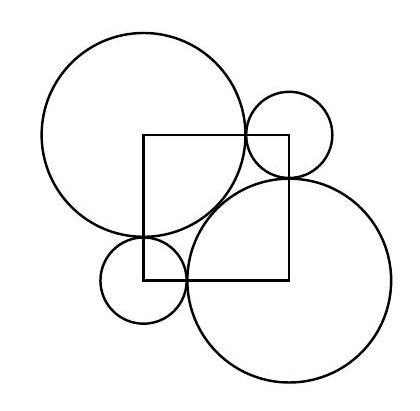How can the information from the image be applied in the real world? Designs such as the one shown can be found in various engineering and architectural contexts. Understanding the relationship between different geometric shapes is crucial in tasks involving packing, covering certain areas with minimal material, or designing objects that fit together in specific ways, like gears or components of a machine. In art, similar configurations can serve as the basis for patterns and motifs used in decorations and graphical compositions. 